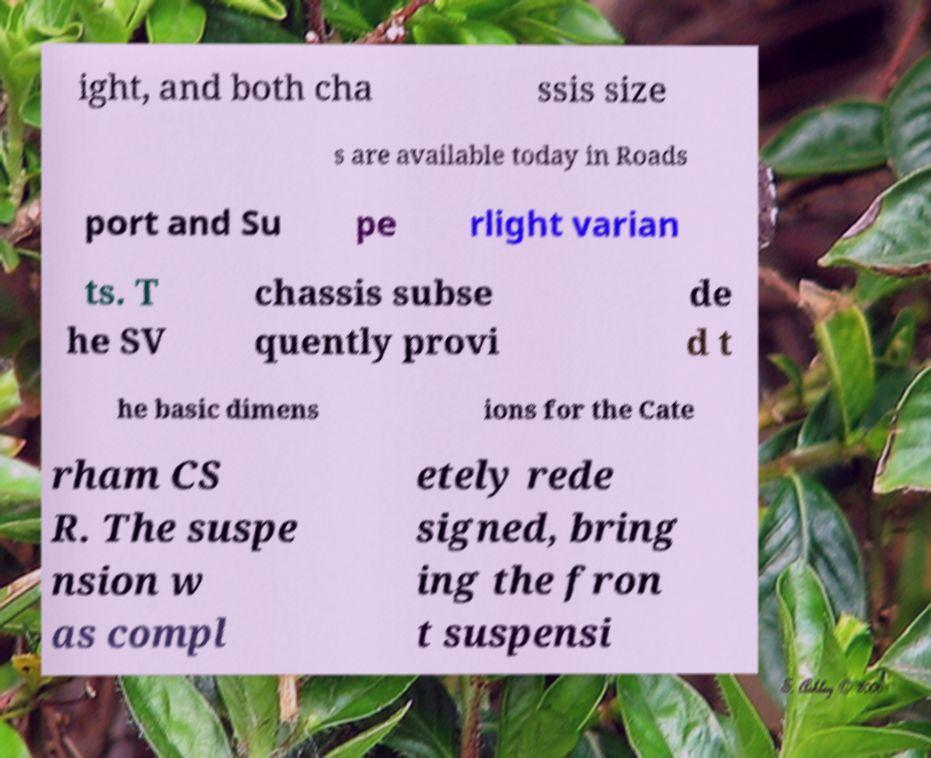Please identify and transcribe the text found in this image. ight, and both cha ssis size s are available today in Roads port and Su pe rlight varian ts. T he SV chassis subse quently provi de d t he basic dimens ions for the Cate rham CS R. The suspe nsion w as compl etely rede signed, bring ing the fron t suspensi 